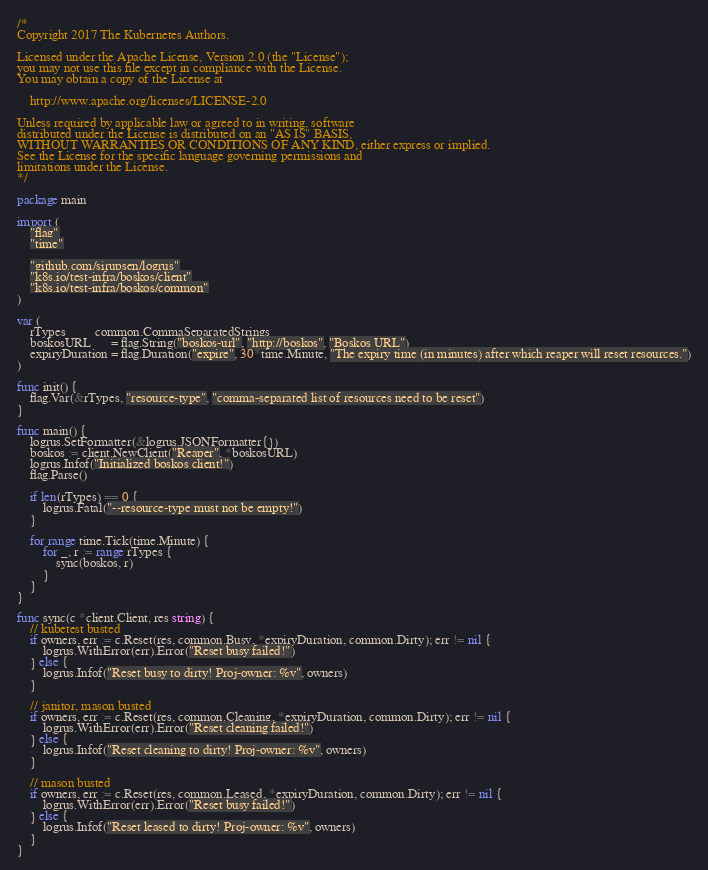<code> <loc_0><loc_0><loc_500><loc_500><_Go_>/*
Copyright 2017 The Kubernetes Authors.

Licensed under the Apache License, Version 2.0 (the "License");
you may not use this file except in compliance with the License.
You may obtain a copy of the License at

    http://www.apache.org/licenses/LICENSE-2.0

Unless required by applicable law or agreed to in writing, software
distributed under the License is distributed on an "AS IS" BASIS,
WITHOUT WARRANTIES OR CONDITIONS OF ANY KIND, either express or implied.
See the License for the specific language governing permissions and
limitations under the License.
*/

package main

import (
	"flag"
	"time"

	"github.com/sirupsen/logrus"
	"k8s.io/test-infra/boskos/client"
	"k8s.io/test-infra/boskos/common"
)

var (
	rTypes         common.CommaSeparatedStrings
	boskosURL      = flag.String("boskos-url", "http://boskos", "Boskos URL")
	expiryDuration = flag.Duration("expire", 30*time.Minute, "The expiry time (in minutes) after which reaper will reset resources.")
)

func init() {
	flag.Var(&rTypes, "resource-type", "comma-separated list of resources need to be reset")
}

func main() {
	logrus.SetFormatter(&logrus.JSONFormatter{})
	boskos := client.NewClient("Reaper", *boskosURL)
	logrus.Infof("Initialized boskos client!")
	flag.Parse()

	if len(rTypes) == 0 {
		logrus.Fatal("--resource-type must not be empty!")
	}

	for range time.Tick(time.Minute) {
		for _, r := range rTypes {
			sync(boskos, r)
		}
	}
}

func sync(c *client.Client, res string) {
	// kubetest busted
	if owners, err := c.Reset(res, common.Busy, *expiryDuration, common.Dirty); err != nil {
		logrus.WithError(err).Error("Reset busy failed!")
	} else {
		logrus.Infof("Reset busy to dirty! Proj-owner: %v", owners)
	}

	// janitor, mason busted
	if owners, err := c.Reset(res, common.Cleaning, *expiryDuration, common.Dirty); err != nil {
		logrus.WithError(err).Error("Reset cleaning failed!")
	} else {
		logrus.Infof("Reset cleaning to dirty! Proj-owner: %v", owners)
	}

	// mason busted
	if owners, err := c.Reset(res, common.Leased, *expiryDuration, common.Dirty); err != nil {
		logrus.WithError(err).Error("Reset busy failed!")
	} else {
		logrus.Infof("Reset leased to dirty! Proj-owner: %v", owners)
	}
}
</code> 